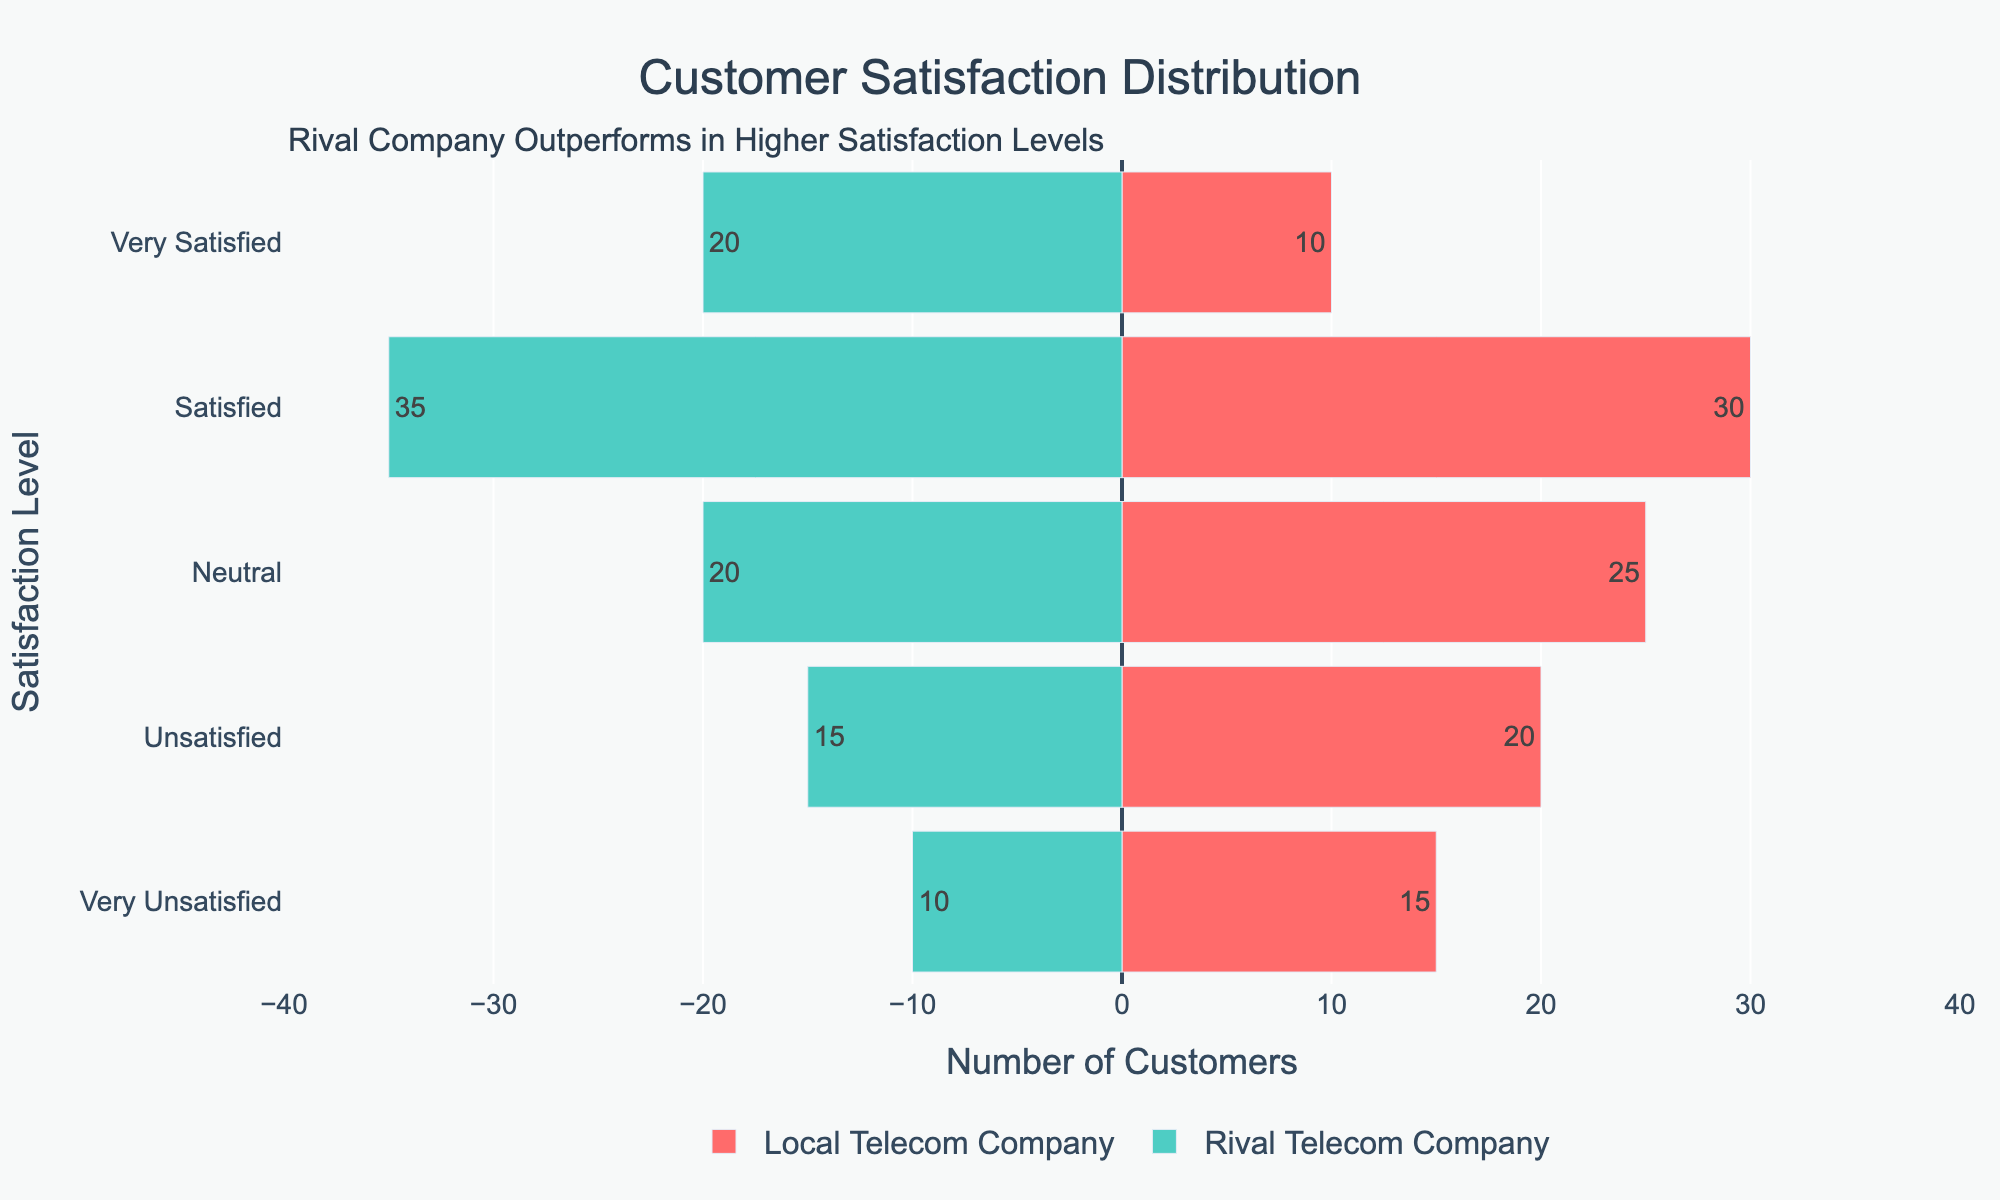What is the total number of "Satisfied" customers for both companies combined? To find the total number of "Satisfied" customers, add the "Satisfied" counts for both the Local Telecom Company and the Rival Telecom Company. Specifically, this is 30 (Local) + 35 (Rival) = 65.
Answer: 65 In which satisfaction level does the Rival Telecom Company have more customers than the Local Telecom Company? Compare the counts of each satisfaction level for the Rival Telecom Company and the Local Telecom Company. The Rival Telecom Company has more customers in the "Satisfied" (35 > 30) and "Very Satisfied" (20 > 10) categories.
Answer: Satisfied and Very Satisfied What is the proportion of "Very Unsatisfied" customers for the Local Telecom Company compared to its total surveyed customers? Calculate the total number of surveyed customers for the Local Telecom Company: 15 (Very Unsatisfied) + 20 (Unsatisfied) + 25 (Neutral) + 30 (Satisfied) + 10 (Very Satisfied) = 100. The proportion of "Very Unsatisfied" customers is 15 / 100 = 0.15 or 15%.
Answer: 15% How does the distribution of "Neutral" customers compare between the two companies? The Local Telecom Company has 25 "Neutral" customers, while the Rival Telecom Company has 20 "Neutral" customers. A comparison shows that the Local Telecom Company has 5 more "Neutral" customers than the Rival Telecom Company.
Answer: Local Telecom Company has 5 more Neutral customers What is the average number of "Satisfied" and "Very Satisfied" customers for the Local Telecom Company? First, find the total number of "Satisfied" and "Very Satisfied" customers: 30 (Satisfied) + 10 (Very Satisfied) = 40. There are 2 categories, so the average is 40 / 2 = 20.
Answer: 20 If you sum the "Unsatisfied" and "Very Unsatisfied" customers for both companies, which one has more? First, sum the "Unsatisfied" and "Very Unsatisfied" customers for each company:
- Local: 15 (Very Unsatisfied) + 20 (Unsatisfied) = 35
- Rival: 10 (Very Unsatisfied) + 15 (Unsatisfied) = 25
The Local Telecom Company has more "Unsatisfied" and "Very Unsatisfied" customers.
Answer: Local Telecom Company How does the Rival Telecom Company compare to the Local Telecom Company in terms of total customers surveyed? Total customers for each company:
- Local: 15 + 20 + 25 + 30 + 10 = 100
- Rival: 10 + 15 + 20 + 35 + 20 = 100
Both companies have the same total number of surveyed customers, 100 each.
Answer: Same, 100 each Considering only the "Very Satisfied" category, what percentage does the Rival Telecom Company's count represent of the total "Very Satisfied" customers? Total "Very Satisfied" = 10 (Local) + 20 (Rival) = 30. The percentage for the Rival Telecom Company is (20 / 30) * 100 = 66.67%.
Answer: 66.67% 